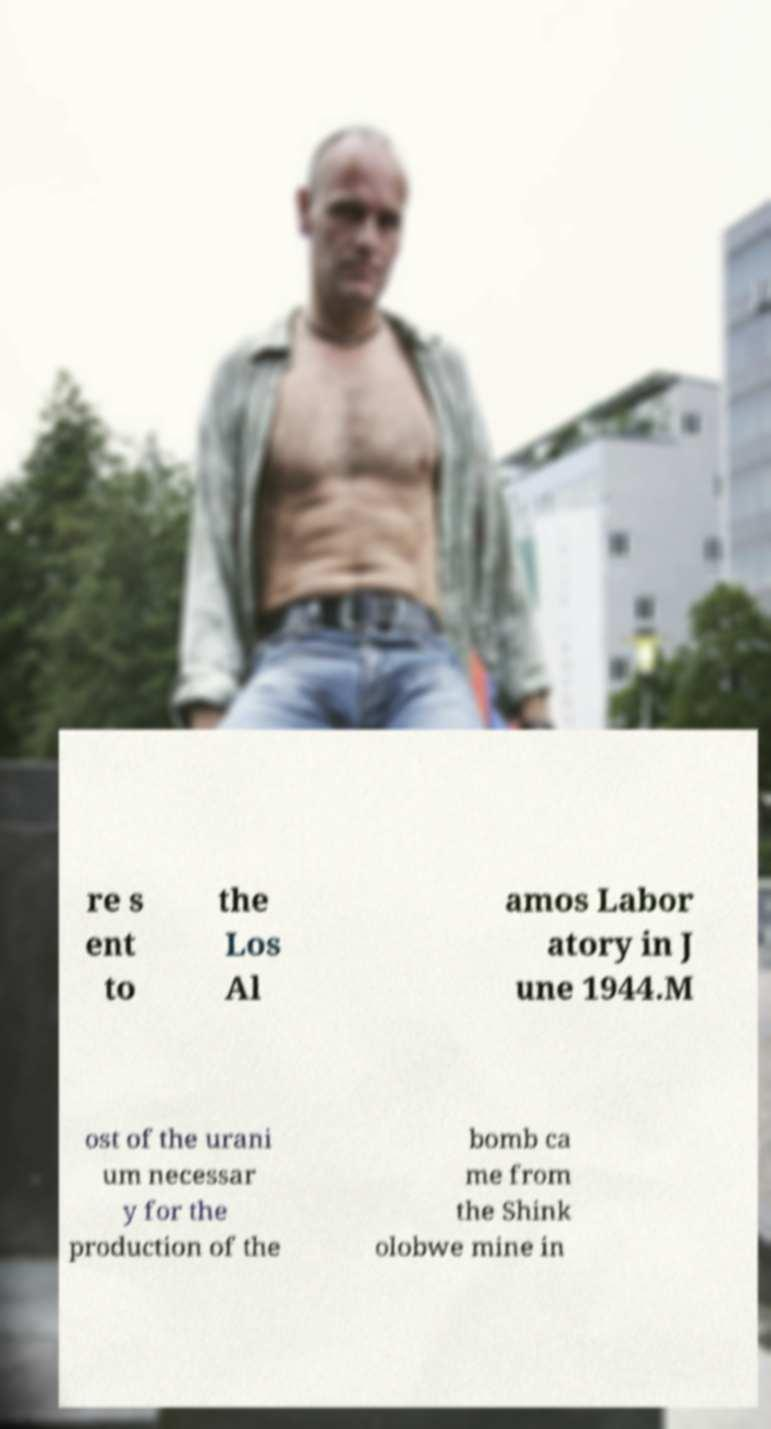Can you accurately transcribe the text from the provided image for me? re s ent to the Los Al amos Labor atory in J une 1944.M ost of the urani um necessar y for the production of the bomb ca me from the Shink olobwe mine in 